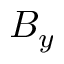<formula> <loc_0><loc_0><loc_500><loc_500>B _ { y }</formula> 